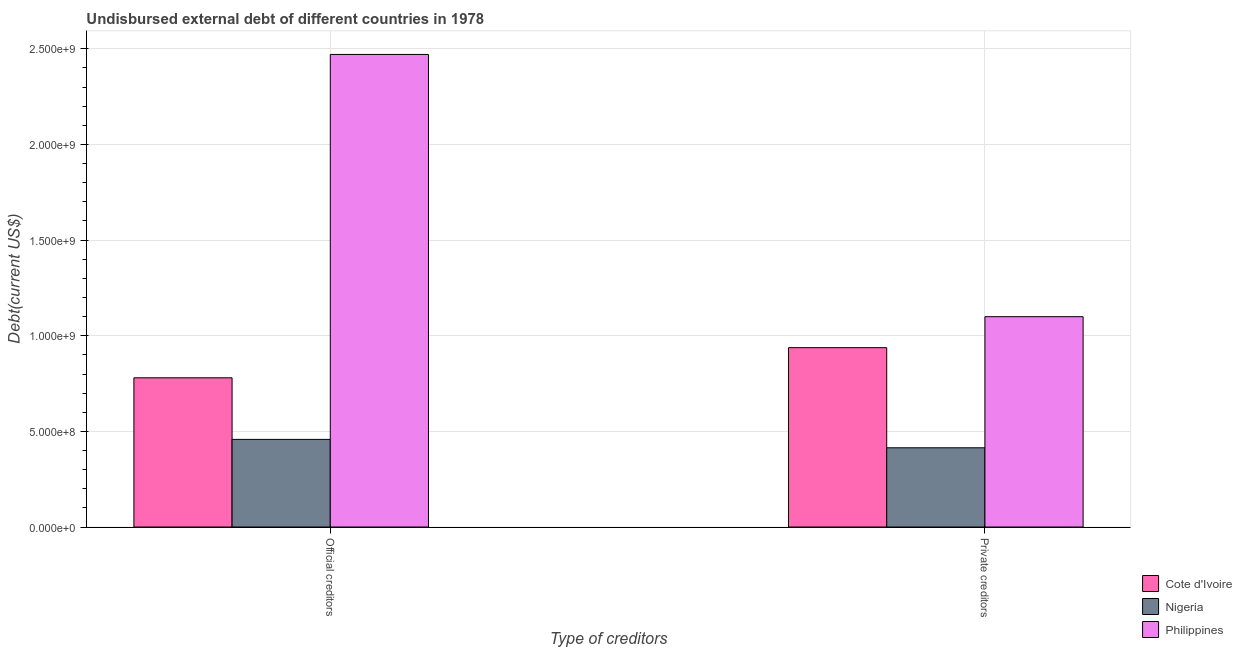How many groups of bars are there?
Offer a terse response. 2. How many bars are there on the 2nd tick from the left?
Your answer should be compact. 3. What is the label of the 2nd group of bars from the left?
Give a very brief answer. Private creditors. What is the undisbursed external debt of official creditors in Cote d'Ivoire?
Your response must be concise. 7.80e+08. Across all countries, what is the maximum undisbursed external debt of private creditors?
Provide a succinct answer. 1.10e+09. Across all countries, what is the minimum undisbursed external debt of official creditors?
Ensure brevity in your answer.  4.58e+08. In which country was the undisbursed external debt of private creditors minimum?
Provide a succinct answer. Nigeria. What is the total undisbursed external debt of private creditors in the graph?
Your response must be concise. 2.45e+09. What is the difference between the undisbursed external debt of official creditors in Cote d'Ivoire and that in Philippines?
Your response must be concise. -1.69e+09. What is the difference between the undisbursed external debt of private creditors in Cote d'Ivoire and the undisbursed external debt of official creditors in Philippines?
Ensure brevity in your answer.  -1.53e+09. What is the average undisbursed external debt of private creditors per country?
Offer a very short reply. 8.17e+08. What is the difference between the undisbursed external debt of private creditors and undisbursed external debt of official creditors in Nigeria?
Give a very brief answer. -4.40e+07. In how many countries, is the undisbursed external debt of private creditors greater than 800000000 US$?
Your answer should be very brief. 2. What is the ratio of the undisbursed external debt of private creditors in Nigeria to that in Cote d'Ivoire?
Your answer should be very brief. 0.44. In how many countries, is the undisbursed external debt of official creditors greater than the average undisbursed external debt of official creditors taken over all countries?
Your answer should be very brief. 1. What does the 1st bar from the left in Official creditors represents?
Give a very brief answer. Cote d'Ivoire. What does the 2nd bar from the right in Private creditors represents?
Your answer should be compact. Nigeria. Are all the bars in the graph horizontal?
Provide a short and direct response. No. How many countries are there in the graph?
Your answer should be very brief. 3. Are the values on the major ticks of Y-axis written in scientific E-notation?
Offer a terse response. Yes. Does the graph contain grids?
Ensure brevity in your answer.  Yes. Where does the legend appear in the graph?
Your response must be concise. Bottom right. How many legend labels are there?
Provide a succinct answer. 3. How are the legend labels stacked?
Provide a succinct answer. Vertical. What is the title of the graph?
Offer a terse response. Undisbursed external debt of different countries in 1978. What is the label or title of the X-axis?
Keep it short and to the point. Type of creditors. What is the label or title of the Y-axis?
Make the answer very short. Debt(current US$). What is the Debt(current US$) in Cote d'Ivoire in Official creditors?
Give a very brief answer. 7.80e+08. What is the Debt(current US$) of Nigeria in Official creditors?
Offer a very short reply. 4.58e+08. What is the Debt(current US$) of Philippines in Official creditors?
Your answer should be very brief. 2.47e+09. What is the Debt(current US$) in Cote d'Ivoire in Private creditors?
Keep it short and to the point. 9.38e+08. What is the Debt(current US$) of Nigeria in Private creditors?
Give a very brief answer. 4.14e+08. What is the Debt(current US$) of Philippines in Private creditors?
Your answer should be compact. 1.10e+09. Across all Type of creditors, what is the maximum Debt(current US$) in Cote d'Ivoire?
Your answer should be compact. 9.38e+08. Across all Type of creditors, what is the maximum Debt(current US$) in Nigeria?
Give a very brief answer. 4.58e+08. Across all Type of creditors, what is the maximum Debt(current US$) in Philippines?
Provide a succinct answer. 2.47e+09. Across all Type of creditors, what is the minimum Debt(current US$) of Cote d'Ivoire?
Provide a short and direct response. 7.80e+08. Across all Type of creditors, what is the minimum Debt(current US$) of Nigeria?
Provide a short and direct response. 4.14e+08. Across all Type of creditors, what is the minimum Debt(current US$) of Philippines?
Give a very brief answer. 1.10e+09. What is the total Debt(current US$) in Cote d'Ivoire in the graph?
Offer a very short reply. 1.72e+09. What is the total Debt(current US$) of Nigeria in the graph?
Offer a very short reply. 8.72e+08. What is the total Debt(current US$) in Philippines in the graph?
Your answer should be very brief. 3.57e+09. What is the difference between the Debt(current US$) in Cote d'Ivoire in Official creditors and that in Private creditors?
Your response must be concise. -1.58e+08. What is the difference between the Debt(current US$) of Nigeria in Official creditors and that in Private creditors?
Keep it short and to the point. 4.40e+07. What is the difference between the Debt(current US$) in Philippines in Official creditors and that in Private creditors?
Ensure brevity in your answer.  1.37e+09. What is the difference between the Debt(current US$) in Cote d'Ivoire in Official creditors and the Debt(current US$) in Nigeria in Private creditors?
Give a very brief answer. 3.66e+08. What is the difference between the Debt(current US$) of Cote d'Ivoire in Official creditors and the Debt(current US$) of Philippines in Private creditors?
Offer a terse response. -3.20e+08. What is the difference between the Debt(current US$) of Nigeria in Official creditors and the Debt(current US$) of Philippines in Private creditors?
Give a very brief answer. -6.41e+08. What is the average Debt(current US$) of Cote d'Ivoire per Type of creditors?
Make the answer very short. 8.59e+08. What is the average Debt(current US$) in Nigeria per Type of creditors?
Offer a terse response. 4.36e+08. What is the average Debt(current US$) in Philippines per Type of creditors?
Your answer should be compact. 1.79e+09. What is the difference between the Debt(current US$) in Cote d'Ivoire and Debt(current US$) in Nigeria in Official creditors?
Give a very brief answer. 3.22e+08. What is the difference between the Debt(current US$) of Cote d'Ivoire and Debt(current US$) of Philippines in Official creditors?
Your answer should be compact. -1.69e+09. What is the difference between the Debt(current US$) of Nigeria and Debt(current US$) of Philippines in Official creditors?
Make the answer very short. -2.01e+09. What is the difference between the Debt(current US$) in Cote d'Ivoire and Debt(current US$) in Nigeria in Private creditors?
Give a very brief answer. 5.23e+08. What is the difference between the Debt(current US$) in Cote d'Ivoire and Debt(current US$) in Philippines in Private creditors?
Offer a very short reply. -1.62e+08. What is the difference between the Debt(current US$) in Nigeria and Debt(current US$) in Philippines in Private creditors?
Ensure brevity in your answer.  -6.85e+08. What is the ratio of the Debt(current US$) of Cote d'Ivoire in Official creditors to that in Private creditors?
Offer a very short reply. 0.83. What is the ratio of the Debt(current US$) of Nigeria in Official creditors to that in Private creditors?
Your answer should be compact. 1.11. What is the ratio of the Debt(current US$) in Philippines in Official creditors to that in Private creditors?
Your answer should be compact. 2.25. What is the difference between the highest and the second highest Debt(current US$) in Cote d'Ivoire?
Provide a short and direct response. 1.58e+08. What is the difference between the highest and the second highest Debt(current US$) in Nigeria?
Your answer should be very brief. 4.40e+07. What is the difference between the highest and the second highest Debt(current US$) in Philippines?
Offer a terse response. 1.37e+09. What is the difference between the highest and the lowest Debt(current US$) of Cote d'Ivoire?
Offer a terse response. 1.58e+08. What is the difference between the highest and the lowest Debt(current US$) of Nigeria?
Ensure brevity in your answer.  4.40e+07. What is the difference between the highest and the lowest Debt(current US$) in Philippines?
Your answer should be compact. 1.37e+09. 